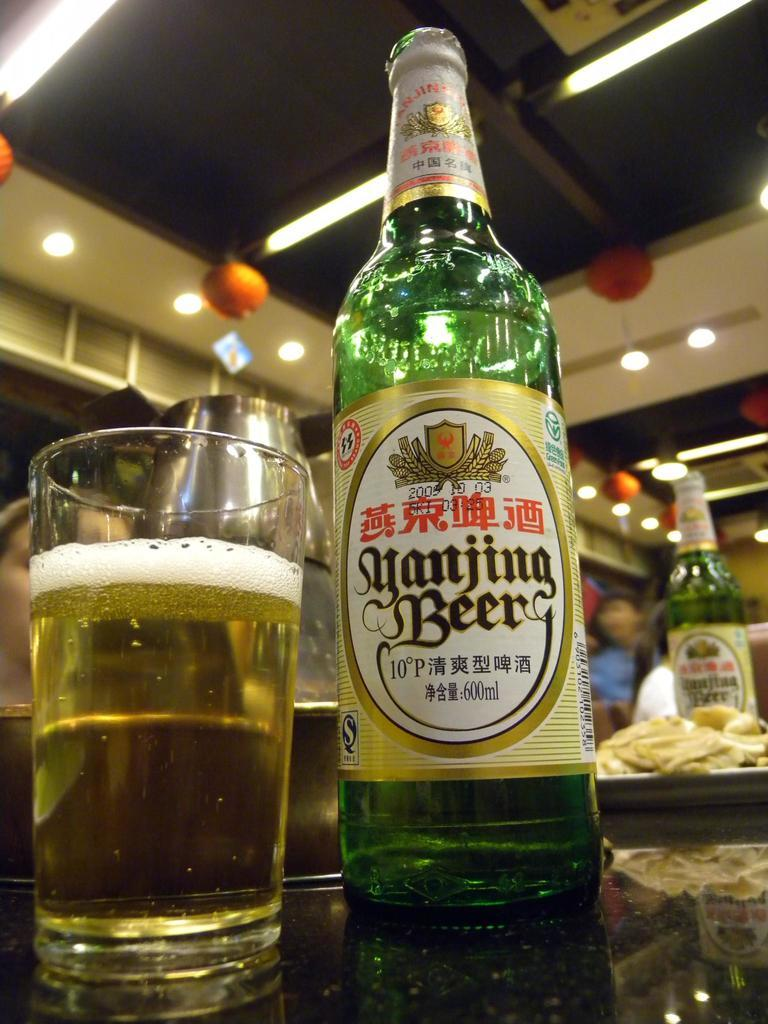<image>
Summarize the visual content of the image. A bottle of beer is next to a full glass. 